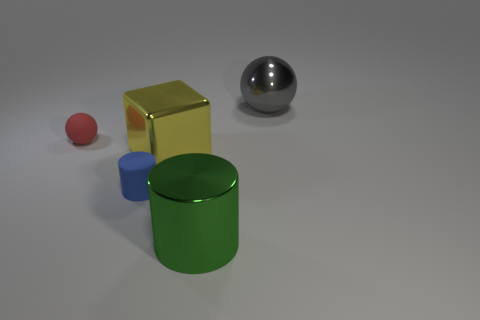Add 1 large cylinders. How many objects exist? 6 Subtract all brown cylinders. Subtract all cubes. How many objects are left? 4 Add 3 metal objects. How many metal objects are left? 6 Add 3 tiny cyan blocks. How many tiny cyan blocks exist? 3 Subtract 0 gray cubes. How many objects are left? 5 Subtract all cylinders. How many objects are left? 3 